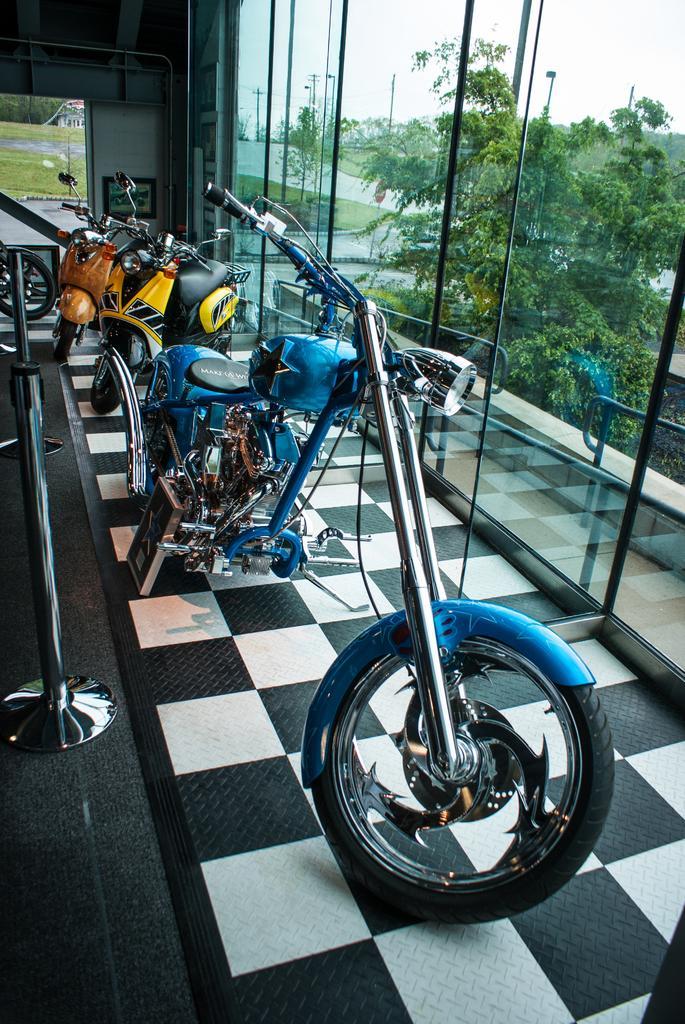Could you give a brief overview of what you see in this image? In the picture I can see the blue color motorbike and two scooters are showcased on the floor which is in black and white. Here we can see stands and the photo frame on the wall in the background. On the right side of the image we can see the glass doors through which we can see the trees, road, current poles and the sky. 